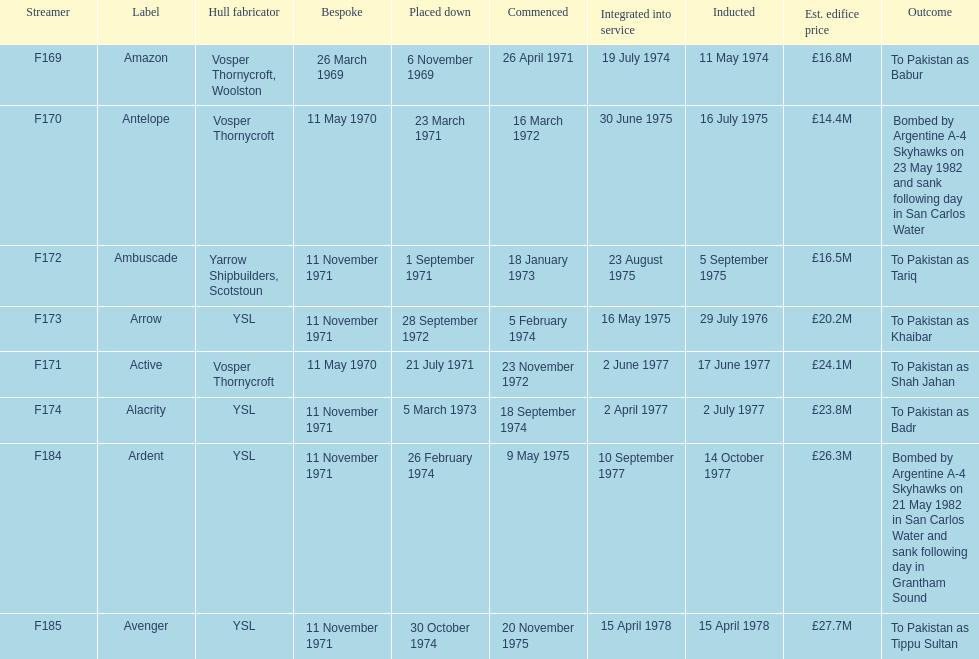Would you be able to parse every entry in this table? {'header': ['Streamer', 'Label', 'Hull fabricator', 'Bespoke', 'Placed down', 'Commenced', 'Integrated into service', 'Inducted', 'Est. edifice price', 'Outcome'], 'rows': [['F169', 'Amazon', 'Vosper Thornycroft, Woolston', '26 March 1969', '6 November 1969', '26 April 1971', '19 July 1974', '11 May 1974', '£16.8M', 'To Pakistan as Babur'], ['F170', 'Antelope', 'Vosper Thornycroft', '11 May 1970', '23 March 1971', '16 March 1972', '30 June 1975', '16 July 1975', '£14.4M', 'Bombed by Argentine A-4 Skyhawks on 23 May 1982 and sank following day in San Carlos Water'], ['F172', 'Ambuscade', 'Yarrow Shipbuilders, Scotstoun', '11 November 1971', '1 September 1971', '18 January 1973', '23 August 1975', '5 September 1975', '£16.5M', 'To Pakistan as Tariq'], ['F173', 'Arrow', 'YSL', '11 November 1971', '28 September 1972', '5 February 1974', '16 May 1975', '29 July 1976', '£20.2M', 'To Pakistan as Khaibar'], ['F171', 'Active', 'Vosper Thornycroft', '11 May 1970', '21 July 1971', '23 November 1972', '2 June 1977', '17 June 1977', '£24.1M', 'To Pakistan as Shah Jahan'], ['F174', 'Alacrity', 'YSL', '11 November 1971', '5 March 1973', '18 September 1974', '2 April 1977', '2 July 1977', '£23.8M', 'To Pakistan as Badr'], ['F184', 'Ardent', 'YSL', '11 November 1971', '26 February 1974', '9 May 1975', '10 September 1977', '14 October 1977', '£26.3M', 'Bombed by Argentine A-4 Skyhawks on 21 May 1982 in San Carlos Water and sank following day in Grantham Sound'], ['F185', 'Avenger', 'YSL', '11 November 1971', '30 October 1974', '20 November 1975', '15 April 1978', '15 April 1978', '£27.7M', 'To Pakistan as Tippu Sultan']]} What is the next pennant after f172? F173. 